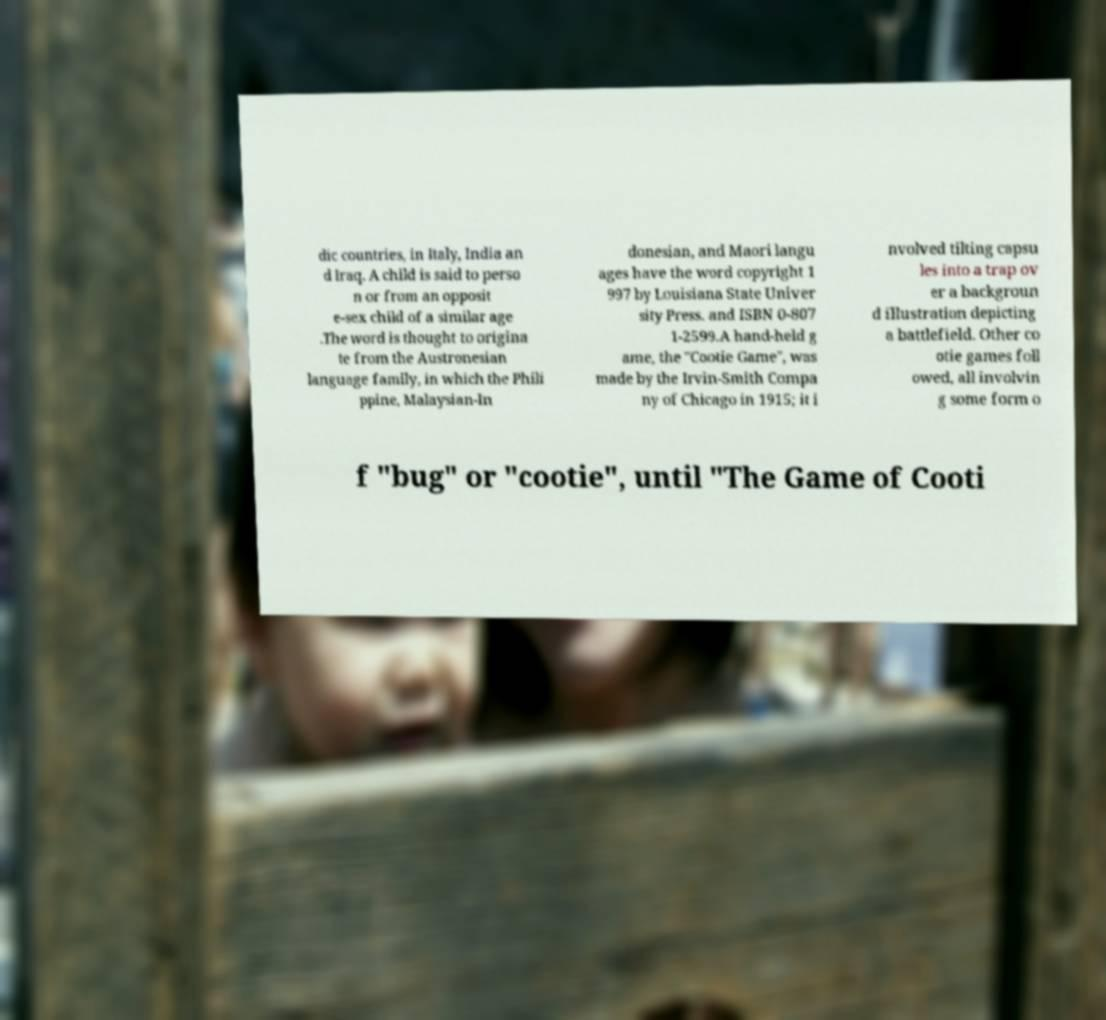Could you extract and type out the text from this image? dic countries, in Italy, India an d Iraq. A child is said to perso n or from an opposit e-sex child of a similar age .The word is thought to origina te from the Austronesian language family, in which the Phili ppine, Malaysian-In donesian, and Maori langu ages have the word copyright 1 997 by Louisiana State Univer sity Press. and ISBN 0-807 1-2599.A hand-held g ame, the "Cootie Game", was made by the Irvin-Smith Compa ny of Chicago in 1915; it i nvolved tilting capsu les into a trap ov er a backgroun d illustration depicting a battlefield. Other co otie games foll owed, all involvin g some form o f "bug" or "cootie", until "The Game of Cooti 